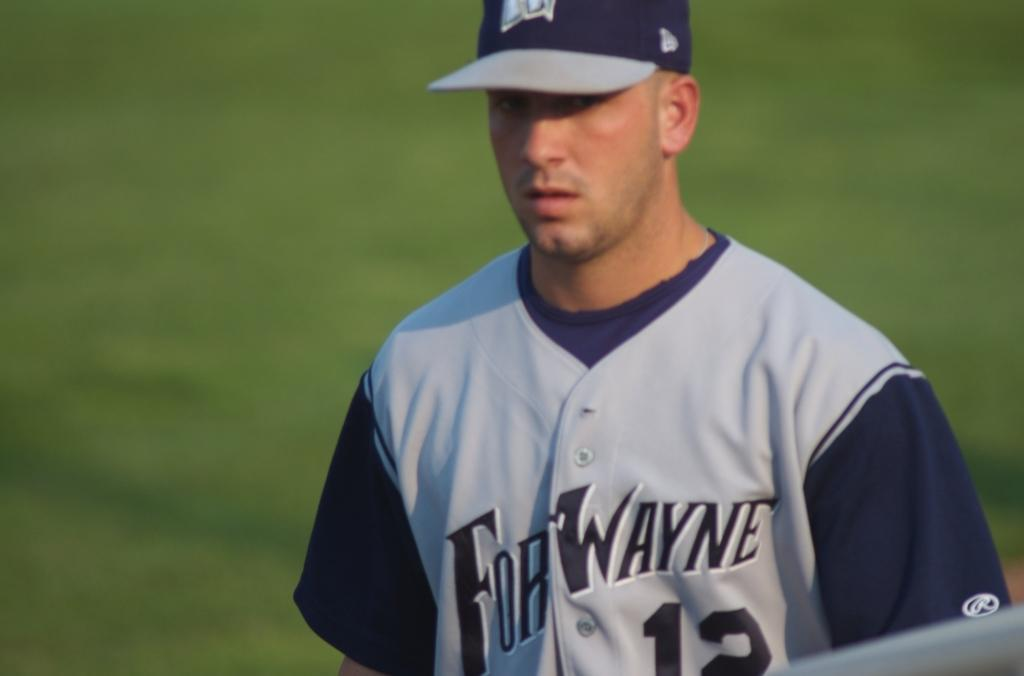<image>
Offer a succinct explanation of the picture presented. A baseball player for Fort Wayne is on the field. 